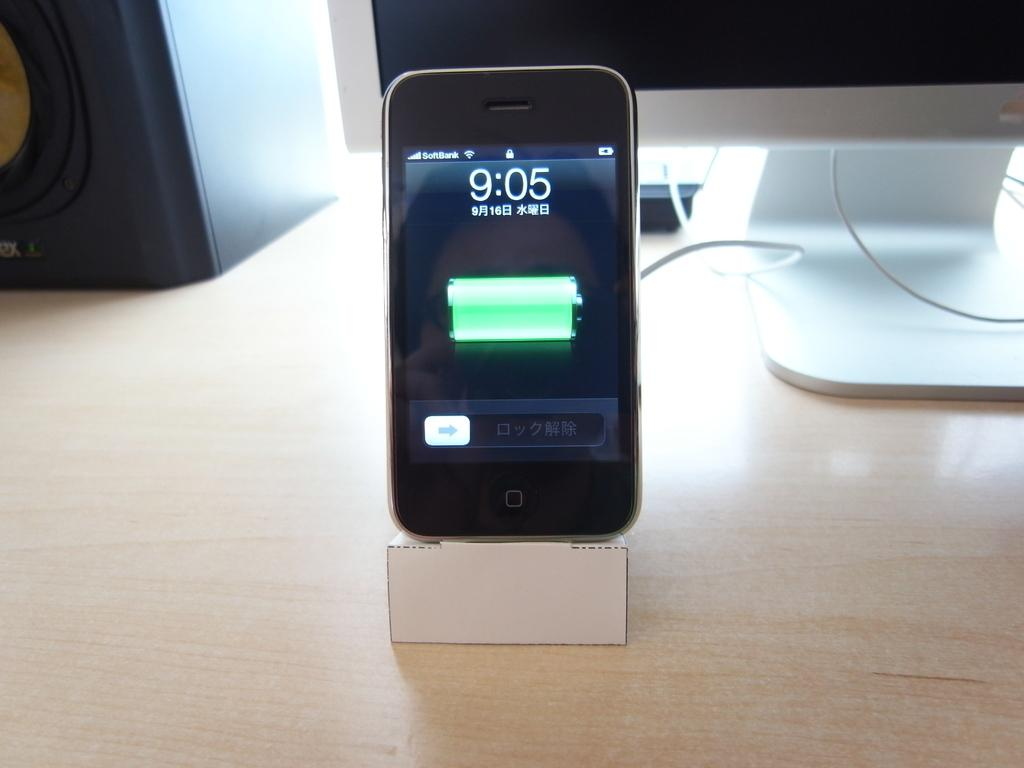<image>
Share a concise interpretation of the image provided. the time is 9:05 that is on a phone 